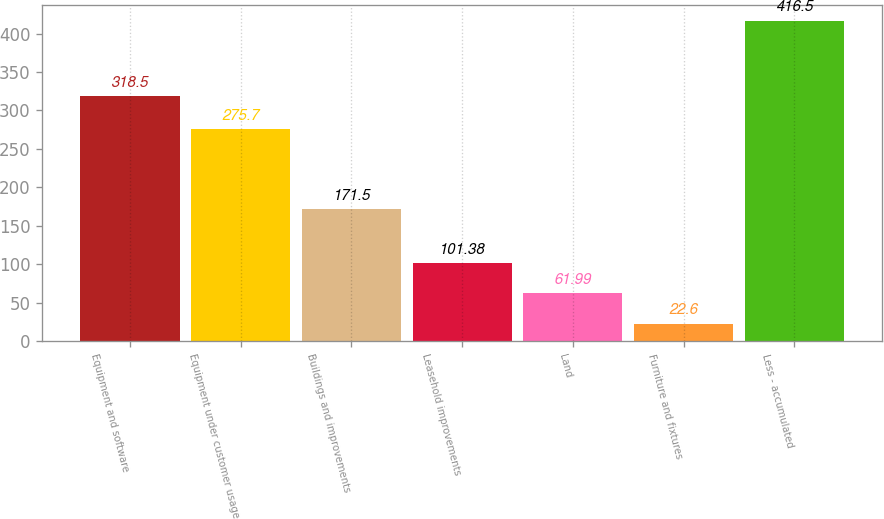<chart> <loc_0><loc_0><loc_500><loc_500><bar_chart><fcel>Equipment and software<fcel>Equipment under customer usage<fcel>Buildings and improvements<fcel>Leasehold improvements<fcel>Land<fcel>Furniture and fixtures<fcel>Less - accumulated<nl><fcel>318.5<fcel>275.7<fcel>171.5<fcel>101.38<fcel>61.99<fcel>22.6<fcel>416.5<nl></chart> 